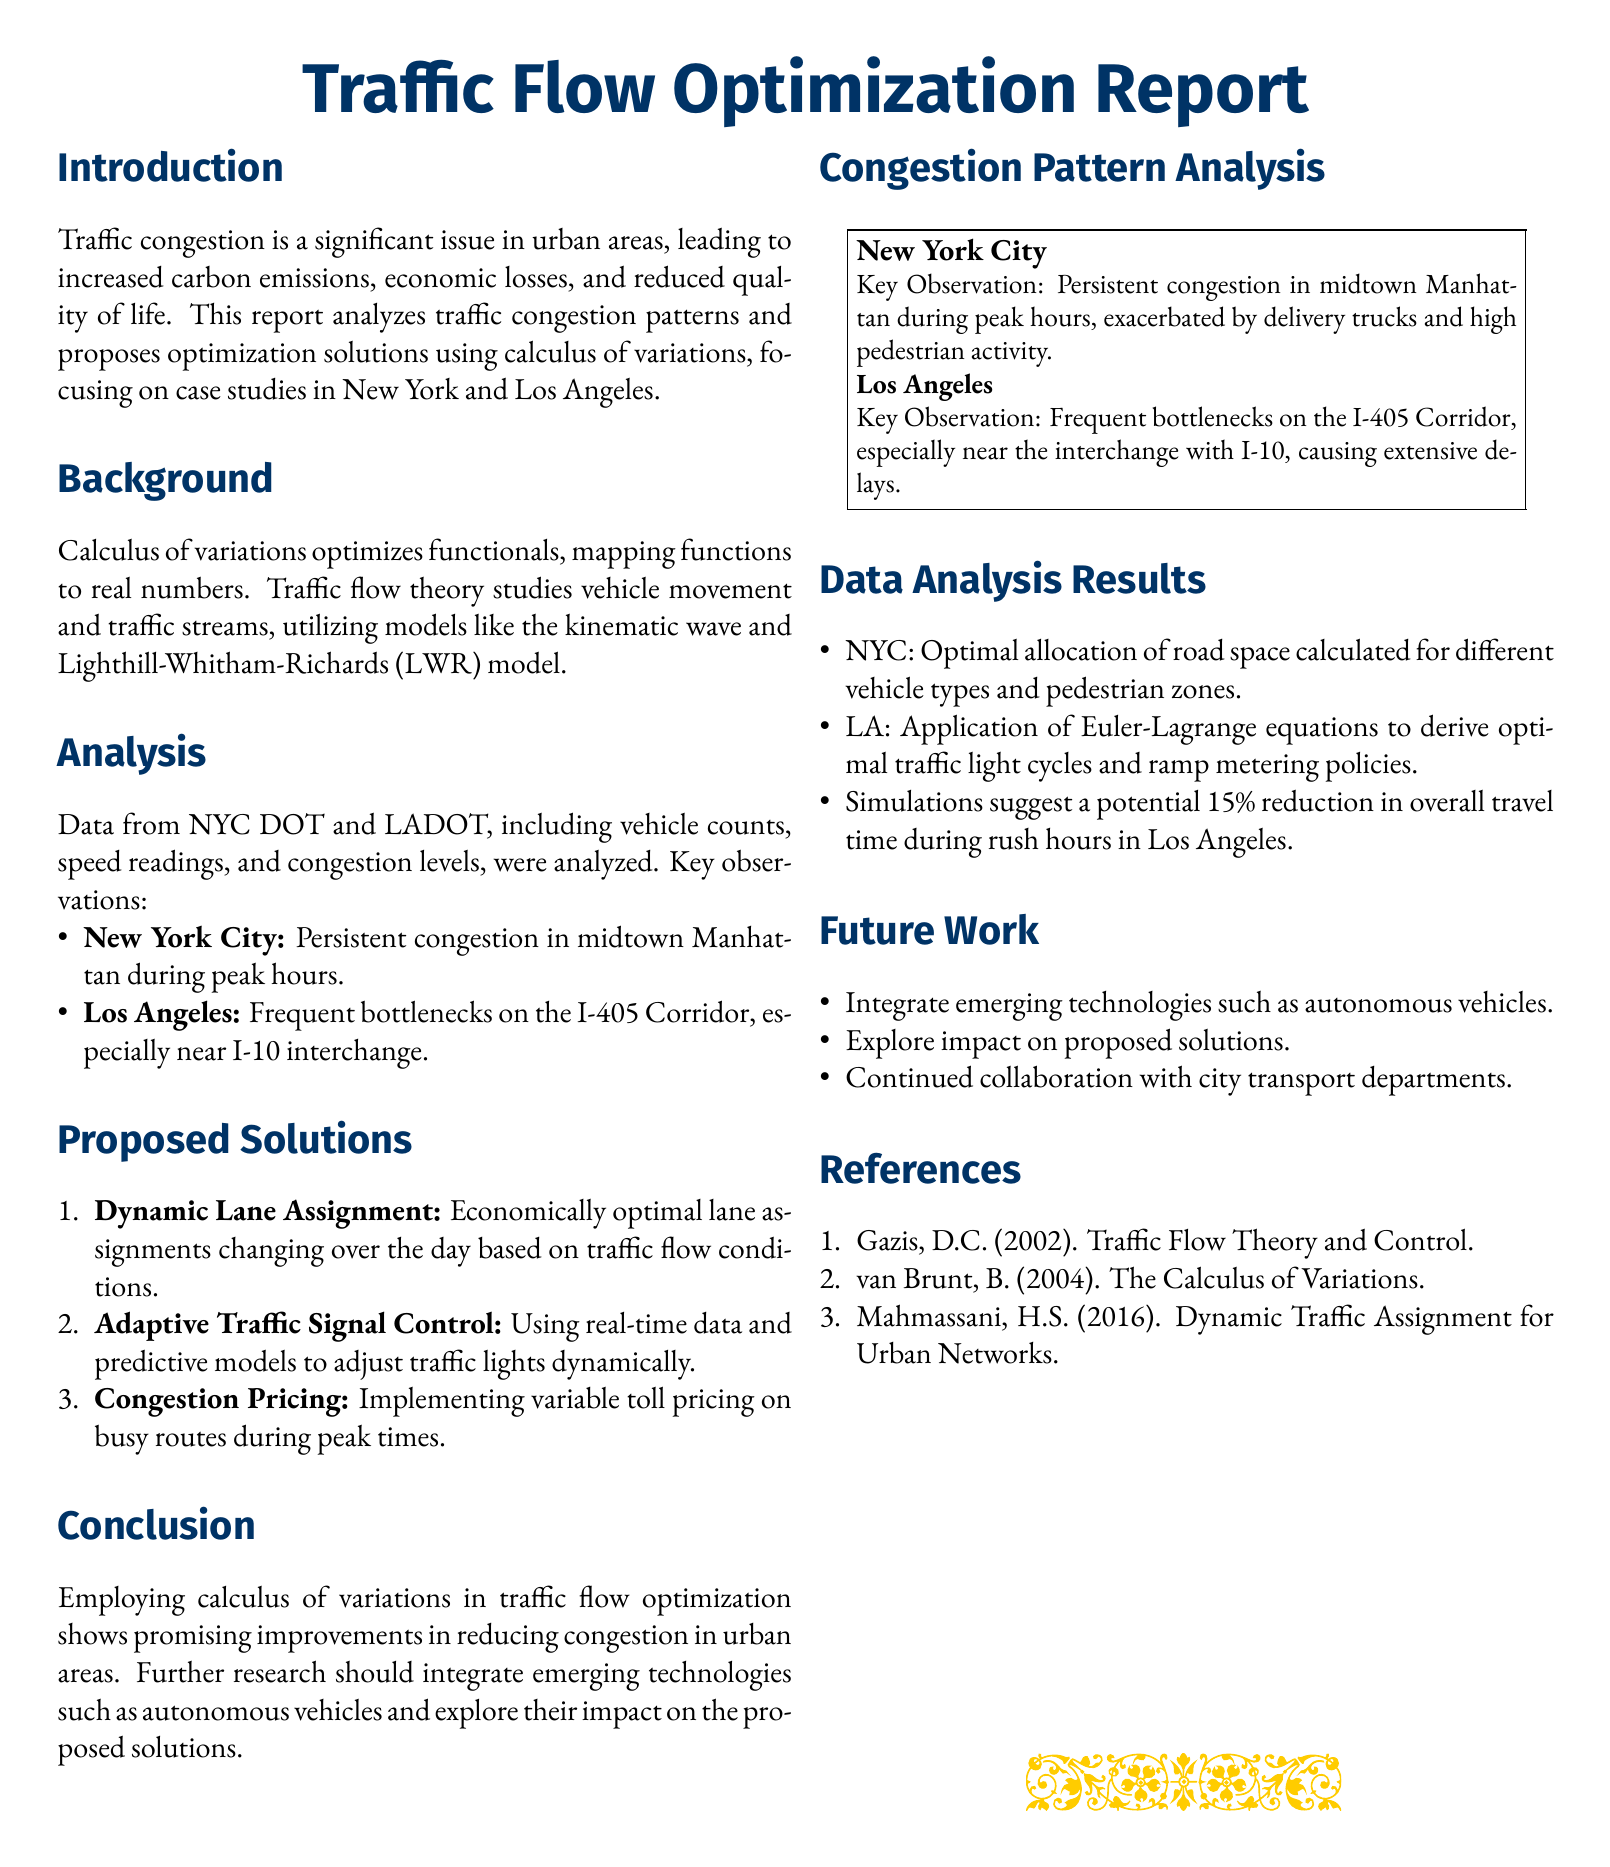What is the title of the report? The title is prominently displayed at the beginning of the document, which is "Traffic Flow Optimization Report."
Answer: Traffic Flow Optimization Report Which two cities were analyzed in the report? The report specifically mentions case studies in New York and Los Angeles.
Answer: New York and Los Angeles What is the key observation for New York City? The document States that there is persistent congestion in midtown Manhattan during peak hours.
Answer: Persistent congestion in midtown Manhattan during peak hours What solution involves changing lane assignments based on traffic flow? The proposed solutions include dynamic lane assignment that allows economically optimal lane changes throughout the day.
Answer: Dynamic Lane Assignment By what percentage could travel time potentially be reduced during rush hours in Los Angeles? The document notes that simulations suggest a potential reduction of 15% in overall travel time during rush hours in Los Angeles.
Answer: 15% What is the main focus of the report? The report analyzes traffic congestion patterns and proposes solutions using calculus of variations.
Answer: Traffic congestion patterns and solutions using calculus of variations Which mathematical equations were used in Los Angeles data analysis? The analysis in Los Angeles applied the Euler-Lagrange equations for optimization.
Answer: Euler-Lagrange equations What future research direction is mentioned in the report? The document suggests integrating emerging technologies, such as autonomous vehicles, into future research.
Answer: Integrate emerging technologies such as autonomous vehicles 